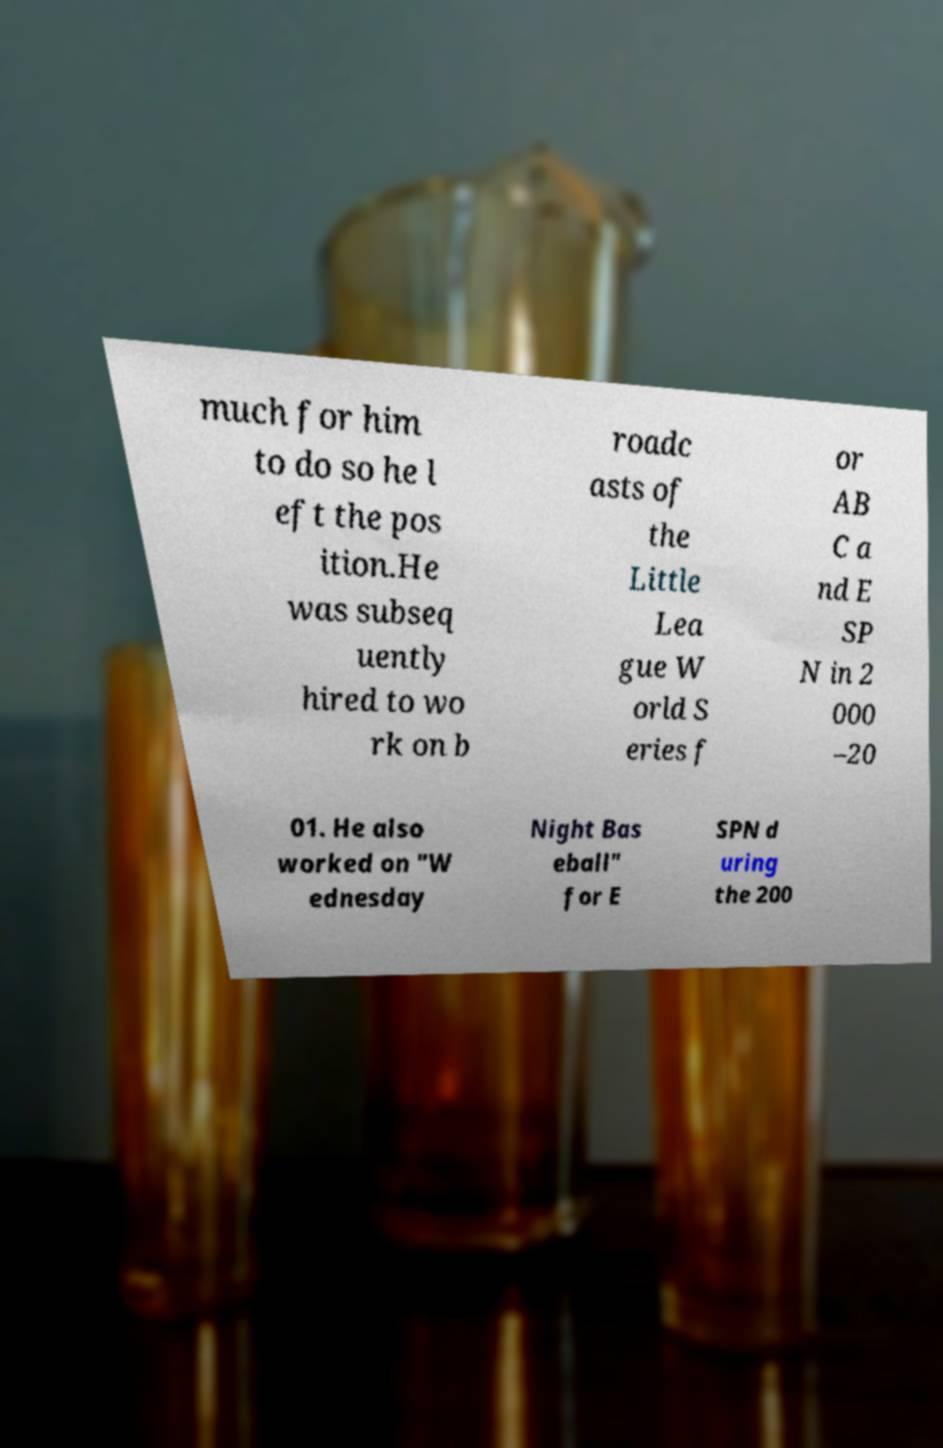Please read and relay the text visible in this image. What does it say? much for him to do so he l eft the pos ition.He was subseq uently hired to wo rk on b roadc asts of the Little Lea gue W orld S eries f or AB C a nd E SP N in 2 000 –20 01. He also worked on "W ednesday Night Bas eball" for E SPN d uring the 200 